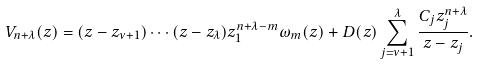<formula> <loc_0><loc_0><loc_500><loc_500>V _ { n + \lambda } ( z ) = ( z - z _ { \nu + 1 } ) \cdots ( z - z _ { \lambda } ) z _ { 1 } ^ { n + \lambda - m } \omega _ { m } ( z ) + D ( z ) \sum _ { j = \nu + 1 } ^ { \lambda } \frac { C _ { j } z _ { j } ^ { n + \lambda } } { z - z _ { j } } .</formula> 